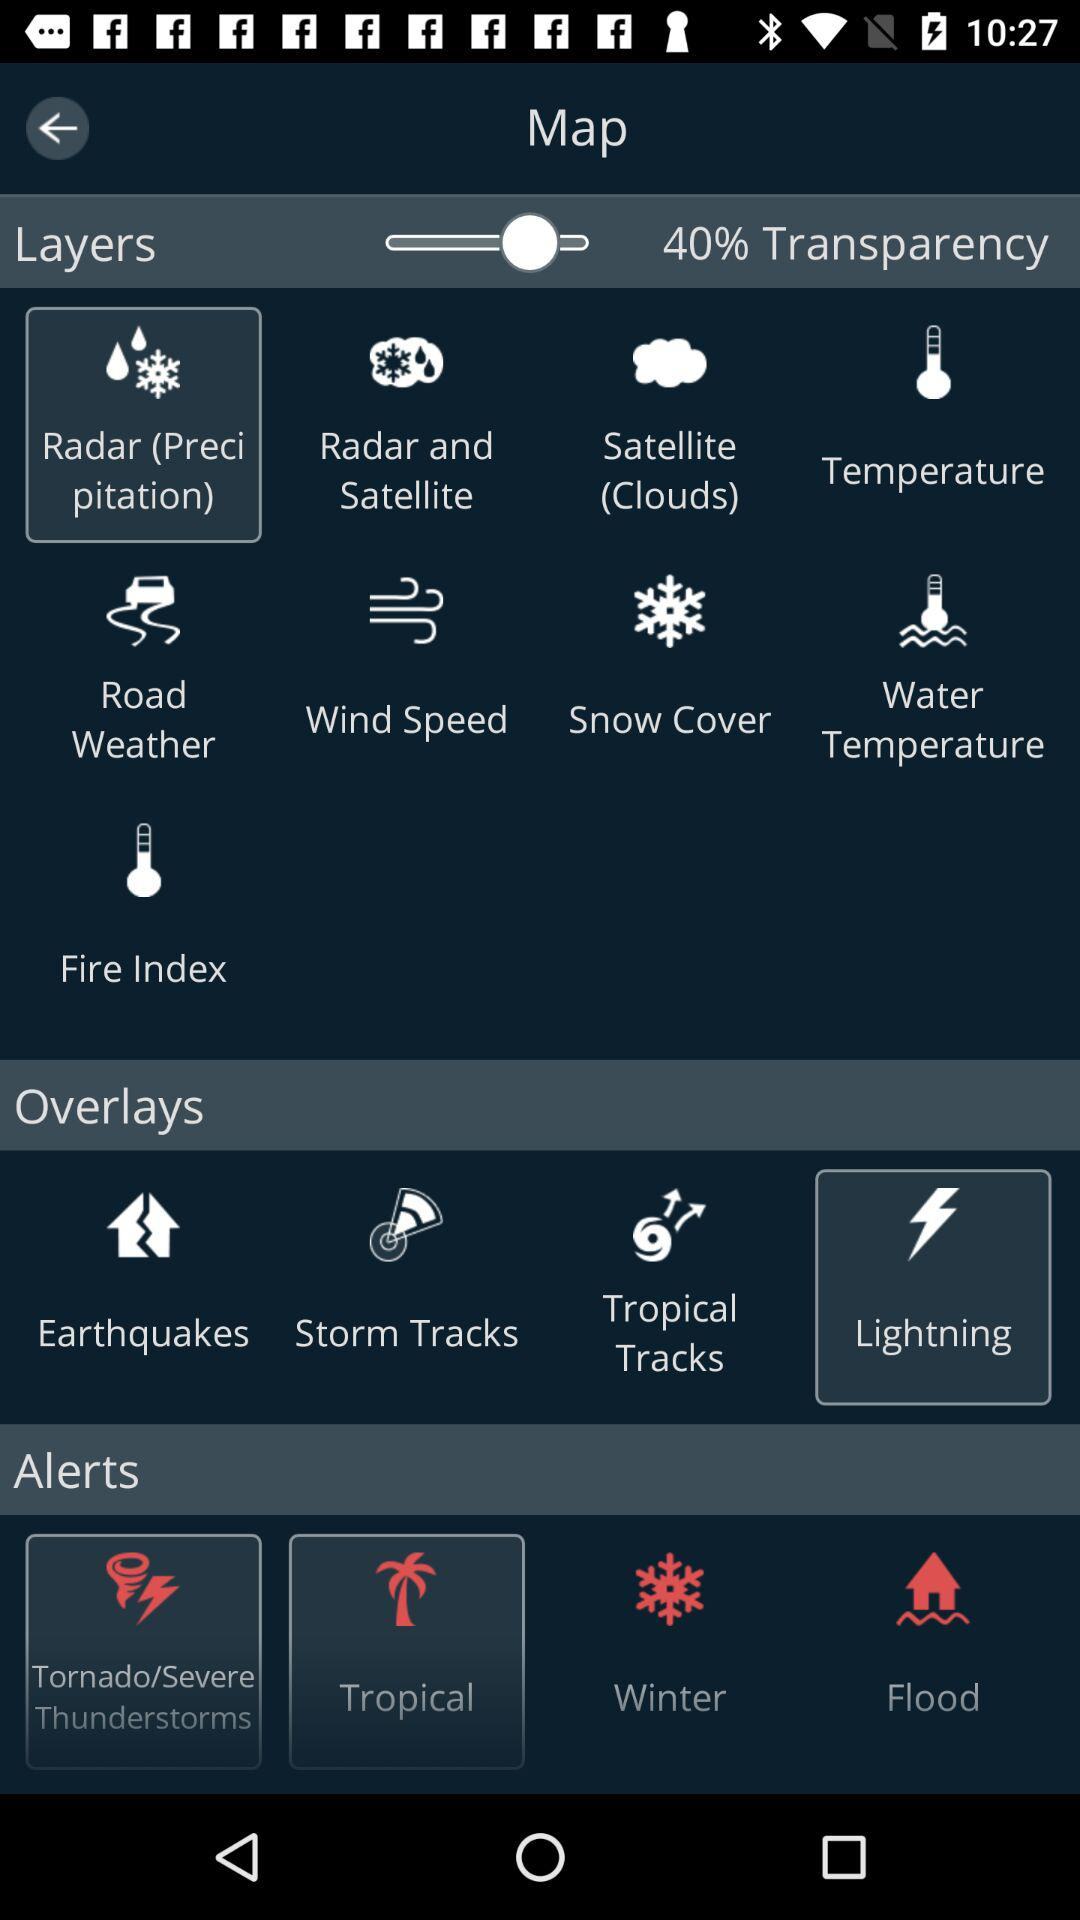Which option is selected in layers? The selected option in layers is "Radar (Precipitation)". 